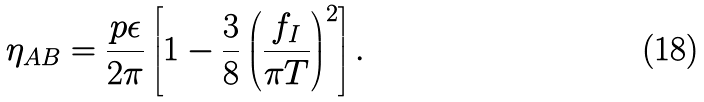Convert formula to latex. <formula><loc_0><loc_0><loc_500><loc_500>\eta _ { A B } = \frac { p \epsilon } { 2 \pi } \left [ 1 - \frac { 3 } { 8 } \left ( \frac { f _ { I } } { \pi T } \right ) ^ { 2 } \right ] .</formula> 